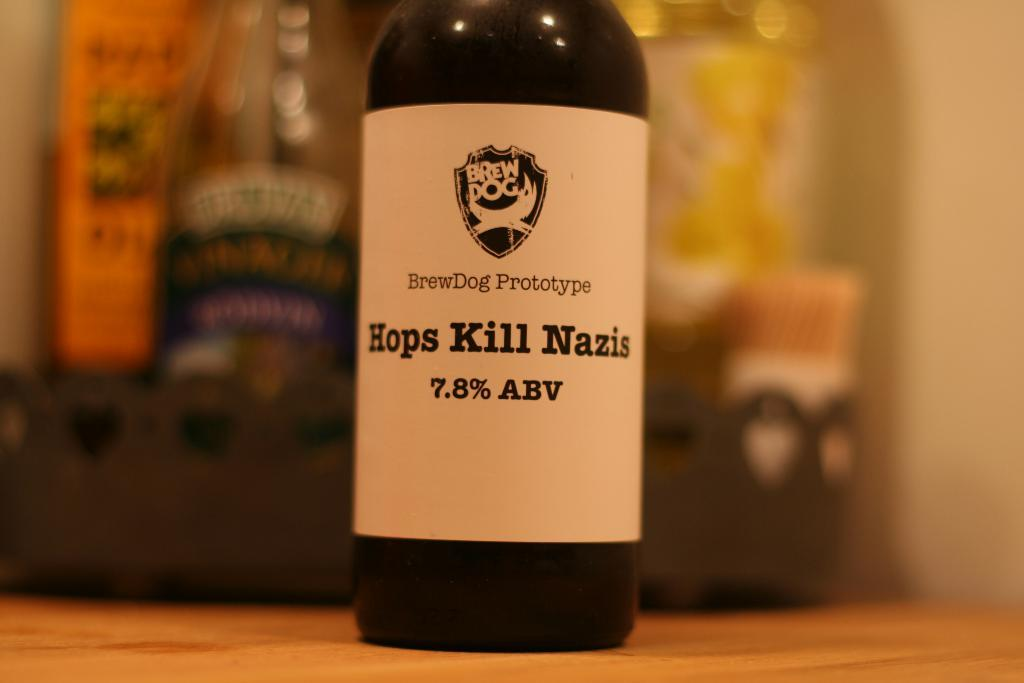<image>
Share a concise interpretation of the image provided. A Brew Dog beer called Hops Kills Nazis. 